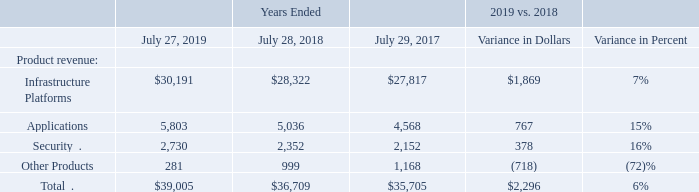Product Revenue by Groups of Similar Products
In addition to the primary view on a geographic basis, we also prepare financial information related to groups of similar products and customer markets for various purposes. We report our product revenue in the following categories: Infrastructure Platforms, Applications, Security, and Other Products. This aligns our product categories with our evolving business model. Prior period amounts have been reclassified to conform to the current period’s presentation.
The following table presents revenue for groups of similar products (in millions, except percentages):
Amounts may not sum and percentages may not recalculate due to rounding.
Infrastructure Platforms The Infrastructure Platforms product category represents our core networking offerings related to switching, routing, wireless, and the data center. Infrastructure Platforms revenue increased by 7%, or $1,869 million, with growth across the portfolio. Switching had solid growth, with strong revenue growth in campus switching driven by an increase in sales of our intent-based networking Catalyst 9000 Series, and with growth in data center switching driven by increased revenue from our ACI portfolio. Routing experienced modest revenue growth driven by an increase in sales of SD-WAN products, partially offset by weakness in the service provider market. We experienced double digit revenue growth from wireless products driven by increases across the portfolio. Revenue from data center increased driven by higher sales of HyperFlex and our server products.
Applications The Applications product category includes our collaboration offerings (unified communications, Cisco TelePresence and conferencing) as well as IoT and AppDynamics analytics software offerings. Revenue in our Applications product category increased by 15%, or $767 million, with double digit growth in unified communications, TelePresence, AppDynamics, and IoT software.
Security Revenue in our Security product category increased 16%, or $378 million, driven by higher sales of identity and access, advanced threat security, unified threat management and web security products. The Duo acquisition in the first quarter of fiscal 2019 also contributed to the revenue increase in this product category.
Other Products The decrease in revenue from our Other Products category was primarily driven by a decrease in revenue from SPVSS business which we divested on October 28, 2018.
Which categories does the company report its product revenue? Infrastructure platforms, applications, security, other products. What was the revenue from Security in 2019?
Answer scale should be: million. 2,730. What was the revenue from Other products in 2018?
Answer scale should be: million. 999. What was the change in revenue from security between 2017 and 2018?
Answer scale should be: million. 2,352-2,152
Answer: 200. How many years did revenue from infrastructure platforms exceed $30,000 million? 2019
Answer: 1. What was the percentage change in total revenue between 2017 and 2018?
Answer scale should be: percent. (36,709-35,705)/35,705
Answer: 2.81. 